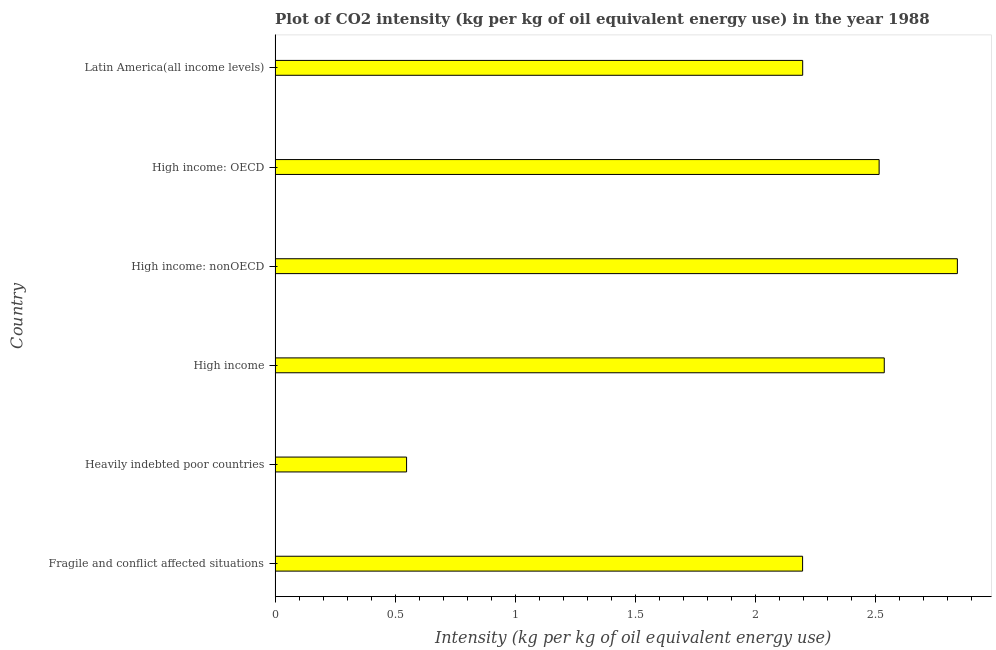What is the title of the graph?
Your answer should be very brief. Plot of CO2 intensity (kg per kg of oil equivalent energy use) in the year 1988. What is the label or title of the X-axis?
Offer a very short reply. Intensity (kg per kg of oil equivalent energy use). What is the co2 intensity in High income: OECD?
Provide a short and direct response. 2.51. Across all countries, what is the maximum co2 intensity?
Provide a short and direct response. 2.84. Across all countries, what is the minimum co2 intensity?
Provide a short and direct response. 0.55. In which country was the co2 intensity maximum?
Ensure brevity in your answer.  High income: nonOECD. In which country was the co2 intensity minimum?
Your answer should be very brief. Heavily indebted poor countries. What is the sum of the co2 intensity?
Keep it short and to the point. 12.83. What is the difference between the co2 intensity in Fragile and conflict affected situations and High income: nonOECD?
Give a very brief answer. -0.64. What is the average co2 intensity per country?
Give a very brief answer. 2.14. What is the median co2 intensity?
Offer a terse response. 2.36. In how many countries, is the co2 intensity greater than 2 kg?
Make the answer very short. 5. What is the ratio of the co2 intensity in High income to that in Latin America(all income levels)?
Offer a terse response. 1.16. What is the difference between the highest and the second highest co2 intensity?
Provide a succinct answer. 0.3. Is the sum of the co2 intensity in High income and Latin America(all income levels) greater than the maximum co2 intensity across all countries?
Make the answer very short. Yes. What is the difference between the highest and the lowest co2 intensity?
Keep it short and to the point. 2.29. Are all the bars in the graph horizontal?
Offer a terse response. Yes. What is the Intensity (kg per kg of oil equivalent energy use) of Fragile and conflict affected situations?
Your answer should be compact. 2.2. What is the Intensity (kg per kg of oil equivalent energy use) of Heavily indebted poor countries?
Ensure brevity in your answer.  0.55. What is the Intensity (kg per kg of oil equivalent energy use) in High income?
Keep it short and to the point. 2.54. What is the Intensity (kg per kg of oil equivalent energy use) in High income: nonOECD?
Your answer should be very brief. 2.84. What is the Intensity (kg per kg of oil equivalent energy use) of High income: OECD?
Provide a succinct answer. 2.51. What is the Intensity (kg per kg of oil equivalent energy use) of Latin America(all income levels)?
Your response must be concise. 2.2. What is the difference between the Intensity (kg per kg of oil equivalent energy use) in Fragile and conflict affected situations and Heavily indebted poor countries?
Provide a short and direct response. 1.65. What is the difference between the Intensity (kg per kg of oil equivalent energy use) in Fragile and conflict affected situations and High income?
Provide a succinct answer. -0.34. What is the difference between the Intensity (kg per kg of oil equivalent energy use) in Fragile and conflict affected situations and High income: nonOECD?
Provide a succinct answer. -0.64. What is the difference between the Intensity (kg per kg of oil equivalent energy use) in Fragile and conflict affected situations and High income: OECD?
Your answer should be very brief. -0.32. What is the difference between the Intensity (kg per kg of oil equivalent energy use) in Fragile and conflict affected situations and Latin America(all income levels)?
Ensure brevity in your answer.  -0. What is the difference between the Intensity (kg per kg of oil equivalent energy use) in Heavily indebted poor countries and High income?
Make the answer very short. -1.99. What is the difference between the Intensity (kg per kg of oil equivalent energy use) in Heavily indebted poor countries and High income: nonOECD?
Ensure brevity in your answer.  -2.29. What is the difference between the Intensity (kg per kg of oil equivalent energy use) in Heavily indebted poor countries and High income: OECD?
Offer a very short reply. -1.97. What is the difference between the Intensity (kg per kg of oil equivalent energy use) in Heavily indebted poor countries and Latin America(all income levels)?
Keep it short and to the point. -1.65. What is the difference between the Intensity (kg per kg of oil equivalent energy use) in High income and High income: nonOECD?
Your answer should be compact. -0.3. What is the difference between the Intensity (kg per kg of oil equivalent energy use) in High income and High income: OECD?
Keep it short and to the point. 0.02. What is the difference between the Intensity (kg per kg of oil equivalent energy use) in High income and Latin America(all income levels)?
Make the answer very short. 0.34. What is the difference between the Intensity (kg per kg of oil equivalent energy use) in High income: nonOECD and High income: OECD?
Ensure brevity in your answer.  0.33. What is the difference between the Intensity (kg per kg of oil equivalent energy use) in High income: nonOECD and Latin America(all income levels)?
Give a very brief answer. 0.64. What is the difference between the Intensity (kg per kg of oil equivalent energy use) in High income: OECD and Latin America(all income levels)?
Offer a very short reply. 0.32. What is the ratio of the Intensity (kg per kg of oil equivalent energy use) in Fragile and conflict affected situations to that in Heavily indebted poor countries?
Your answer should be compact. 4.01. What is the ratio of the Intensity (kg per kg of oil equivalent energy use) in Fragile and conflict affected situations to that in High income?
Give a very brief answer. 0.87. What is the ratio of the Intensity (kg per kg of oil equivalent energy use) in Fragile and conflict affected situations to that in High income: nonOECD?
Ensure brevity in your answer.  0.77. What is the ratio of the Intensity (kg per kg of oil equivalent energy use) in Fragile and conflict affected situations to that in High income: OECD?
Your answer should be very brief. 0.87. What is the ratio of the Intensity (kg per kg of oil equivalent energy use) in Fragile and conflict affected situations to that in Latin America(all income levels)?
Your response must be concise. 1. What is the ratio of the Intensity (kg per kg of oil equivalent energy use) in Heavily indebted poor countries to that in High income?
Your answer should be compact. 0.22. What is the ratio of the Intensity (kg per kg of oil equivalent energy use) in Heavily indebted poor countries to that in High income: nonOECD?
Ensure brevity in your answer.  0.19. What is the ratio of the Intensity (kg per kg of oil equivalent energy use) in Heavily indebted poor countries to that in High income: OECD?
Offer a very short reply. 0.22. What is the ratio of the Intensity (kg per kg of oil equivalent energy use) in Heavily indebted poor countries to that in Latin America(all income levels)?
Your answer should be compact. 0.25. What is the ratio of the Intensity (kg per kg of oil equivalent energy use) in High income to that in High income: nonOECD?
Your response must be concise. 0.89. What is the ratio of the Intensity (kg per kg of oil equivalent energy use) in High income to that in High income: OECD?
Keep it short and to the point. 1.01. What is the ratio of the Intensity (kg per kg of oil equivalent energy use) in High income to that in Latin America(all income levels)?
Your answer should be compact. 1.16. What is the ratio of the Intensity (kg per kg of oil equivalent energy use) in High income: nonOECD to that in High income: OECD?
Provide a short and direct response. 1.13. What is the ratio of the Intensity (kg per kg of oil equivalent energy use) in High income: nonOECD to that in Latin America(all income levels)?
Your answer should be very brief. 1.29. What is the ratio of the Intensity (kg per kg of oil equivalent energy use) in High income: OECD to that in Latin America(all income levels)?
Your answer should be very brief. 1.15. 